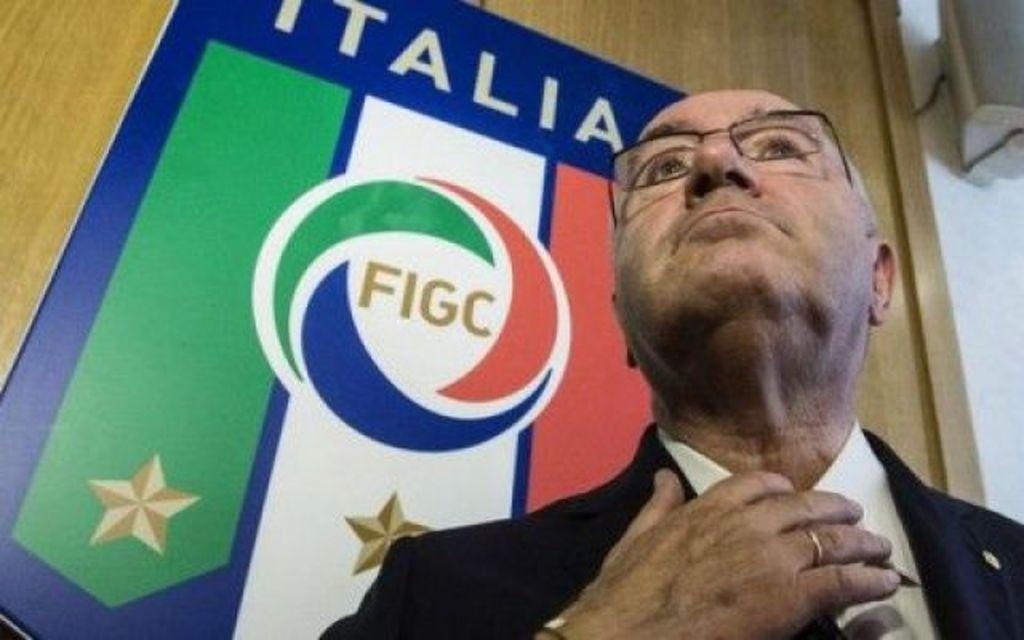Please provide a concise description of this image. In this image I can see a man wearing suit and spectacles. There is a banner on a wooden background. 